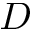<formula> <loc_0><loc_0><loc_500><loc_500>D</formula> 